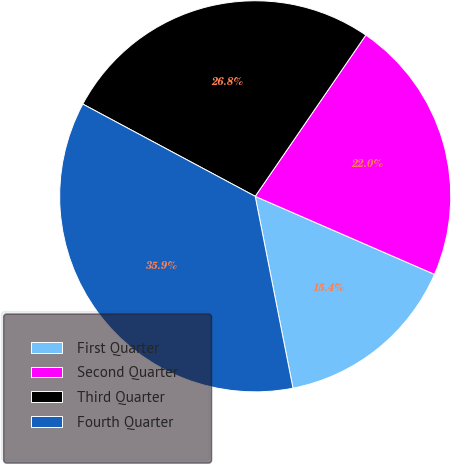<chart> <loc_0><loc_0><loc_500><loc_500><pie_chart><fcel>First Quarter<fcel>Second Quarter<fcel>Third Quarter<fcel>Fourth Quarter<nl><fcel>15.37%<fcel>21.96%<fcel>26.75%<fcel>35.91%<nl></chart> 